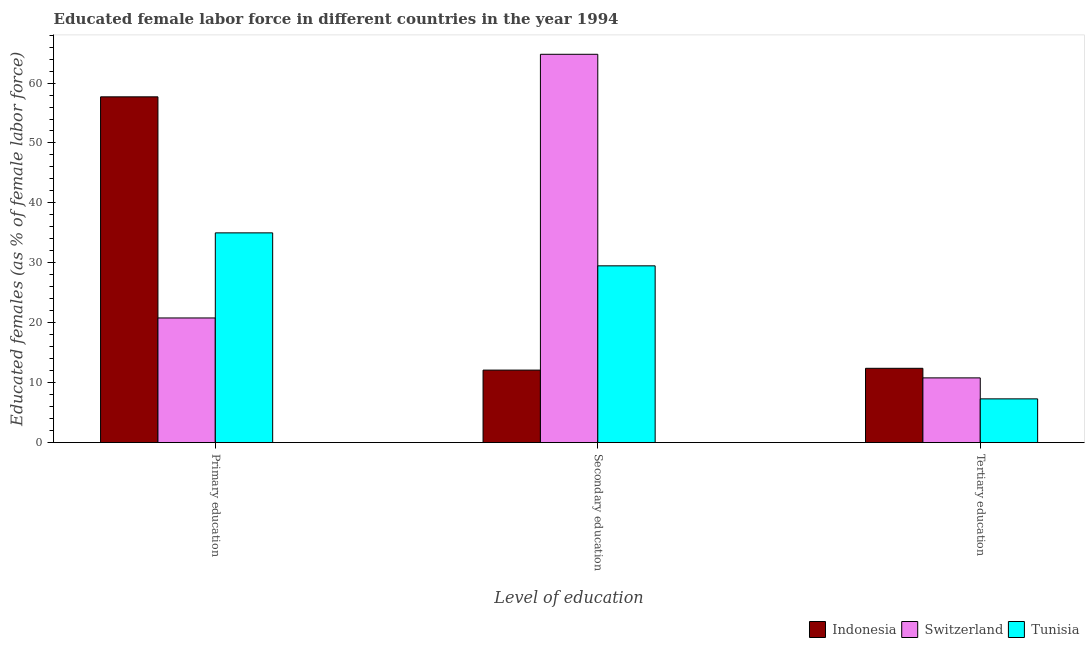How many different coloured bars are there?
Your answer should be compact. 3. How many groups of bars are there?
Make the answer very short. 3. How many bars are there on the 1st tick from the left?
Make the answer very short. 3. What is the percentage of female labor force who received tertiary education in Switzerland?
Offer a very short reply. 10.8. Across all countries, what is the maximum percentage of female labor force who received primary education?
Offer a very short reply. 57.7. Across all countries, what is the minimum percentage of female labor force who received secondary education?
Offer a terse response. 12.1. In which country was the percentage of female labor force who received tertiary education maximum?
Your answer should be compact. Indonesia. In which country was the percentage of female labor force who received secondary education minimum?
Provide a short and direct response. Indonesia. What is the total percentage of female labor force who received primary education in the graph?
Offer a very short reply. 113.5. What is the difference between the percentage of female labor force who received secondary education in Switzerland and that in Tunisia?
Ensure brevity in your answer.  35.3. What is the difference between the percentage of female labor force who received primary education in Indonesia and the percentage of female labor force who received secondary education in Switzerland?
Provide a succinct answer. -7.1. What is the average percentage of female labor force who received tertiary education per country?
Your response must be concise. 10.17. In how many countries, is the percentage of female labor force who received secondary education greater than 66 %?
Make the answer very short. 0. What is the ratio of the percentage of female labor force who received secondary education in Indonesia to that in Switzerland?
Offer a terse response. 0.19. What is the difference between the highest and the second highest percentage of female labor force who received secondary education?
Give a very brief answer. 35.3. What is the difference between the highest and the lowest percentage of female labor force who received primary education?
Give a very brief answer. 36.9. Is the sum of the percentage of female labor force who received secondary education in Indonesia and Switzerland greater than the maximum percentage of female labor force who received tertiary education across all countries?
Offer a terse response. Yes. What does the 2nd bar from the left in Primary education represents?
Offer a terse response. Switzerland. What does the 1st bar from the right in Primary education represents?
Give a very brief answer. Tunisia. Is it the case that in every country, the sum of the percentage of female labor force who received primary education and percentage of female labor force who received secondary education is greater than the percentage of female labor force who received tertiary education?
Your answer should be compact. Yes. How many bars are there?
Ensure brevity in your answer.  9. Are all the bars in the graph horizontal?
Offer a very short reply. No. How many countries are there in the graph?
Provide a short and direct response. 3. What is the difference between two consecutive major ticks on the Y-axis?
Your answer should be compact. 10. Does the graph contain any zero values?
Ensure brevity in your answer.  No. How many legend labels are there?
Your answer should be very brief. 3. What is the title of the graph?
Provide a short and direct response. Educated female labor force in different countries in the year 1994. What is the label or title of the X-axis?
Provide a short and direct response. Level of education. What is the label or title of the Y-axis?
Your answer should be very brief. Educated females (as % of female labor force). What is the Educated females (as % of female labor force) of Indonesia in Primary education?
Your answer should be compact. 57.7. What is the Educated females (as % of female labor force) of Switzerland in Primary education?
Provide a short and direct response. 20.8. What is the Educated females (as % of female labor force) of Tunisia in Primary education?
Make the answer very short. 35. What is the Educated females (as % of female labor force) of Indonesia in Secondary education?
Provide a succinct answer. 12.1. What is the Educated females (as % of female labor force) of Switzerland in Secondary education?
Provide a succinct answer. 64.8. What is the Educated females (as % of female labor force) of Tunisia in Secondary education?
Keep it short and to the point. 29.5. What is the Educated females (as % of female labor force) in Indonesia in Tertiary education?
Ensure brevity in your answer.  12.4. What is the Educated females (as % of female labor force) in Switzerland in Tertiary education?
Offer a terse response. 10.8. What is the Educated females (as % of female labor force) in Tunisia in Tertiary education?
Provide a succinct answer. 7.3. Across all Level of education, what is the maximum Educated females (as % of female labor force) of Indonesia?
Ensure brevity in your answer.  57.7. Across all Level of education, what is the maximum Educated females (as % of female labor force) in Switzerland?
Provide a short and direct response. 64.8. Across all Level of education, what is the minimum Educated females (as % of female labor force) in Indonesia?
Give a very brief answer. 12.1. Across all Level of education, what is the minimum Educated females (as % of female labor force) of Switzerland?
Your response must be concise. 10.8. Across all Level of education, what is the minimum Educated females (as % of female labor force) of Tunisia?
Provide a short and direct response. 7.3. What is the total Educated females (as % of female labor force) in Indonesia in the graph?
Provide a succinct answer. 82.2. What is the total Educated females (as % of female labor force) of Switzerland in the graph?
Keep it short and to the point. 96.4. What is the total Educated females (as % of female labor force) of Tunisia in the graph?
Make the answer very short. 71.8. What is the difference between the Educated females (as % of female labor force) of Indonesia in Primary education and that in Secondary education?
Keep it short and to the point. 45.6. What is the difference between the Educated females (as % of female labor force) in Switzerland in Primary education and that in Secondary education?
Keep it short and to the point. -44. What is the difference between the Educated females (as % of female labor force) of Tunisia in Primary education and that in Secondary education?
Make the answer very short. 5.5. What is the difference between the Educated females (as % of female labor force) in Indonesia in Primary education and that in Tertiary education?
Keep it short and to the point. 45.3. What is the difference between the Educated females (as % of female labor force) in Tunisia in Primary education and that in Tertiary education?
Your answer should be compact. 27.7. What is the difference between the Educated females (as % of female labor force) of Indonesia in Secondary education and that in Tertiary education?
Give a very brief answer. -0.3. What is the difference between the Educated females (as % of female labor force) in Indonesia in Primary education and the Educated females (as % of female labor force) in Switzerland in Secondary education?
Offer a very short reply. -7.1. What is the difference between the Educated females (as % of female labor force) in Indonesia in Primary education and the Educated females (as % of female labor force) in Tunisia in Secondary education?
Provide a short and direct response. 28.2. What is the difference between the Educated females (as % of female labor force) in Switzerland in Primary education and the Educated females (as % of female labor force) in Tunisia in Secondary education?
Ensure brevity in your answer.  -8.7. What is the difference between the Educated females (as % of female labor force) of Indonesia in Primary education and the Educated females (as % of female labor force) of Switzerland in Tertiary education?
Your response must be concise. 46.9. What is the difference between the Educated females (as % of female labor force) of Indonesia in Primary education and the Educated females (as % of female labor force) of Tunisia in Tertiary education?
Ensure brevity in your answer.  50.4. What is the difference between the Educated females (as % of female labor force) of Switzerland in Primary education and the Educated females (as % of female labor force) of Tunisia in Tertiary education?
Give a very brief answer. 13.5. What is the difference between the Educated females (as % of female labor force) of Indonesia in Secondary education and the Educated females (as % of female labor force) of Switzerland in Tertiary education?
Ensure brevity in your answer.  1.3. What is the difference between the Educated females (as % of female labor force) of Switzerland in Secondary education and the Educated females (as % of female labor force) of Tunisia in Tertiary education?
Your answer should be very brief. 57.5. What is the average Educated females (as % of female labor force) in Indonesia per Level of education?
Offer a terse response. 27.4. What is the average Educated females (as % of female labor force) of Switzerland per Level of education?
Offer a terse response. 32.13. What is the average Educated females (as % of female labor force) of Tunisia per Level of education?
Provide a succinct answer. 23.93. What is the difference between the Educated females (as % of female labor force) in Indonesia and Educated females (as % of female labor force) in Switzerland in Primary education?
Offer a very short reply. 36.9. What is the difference between the Educated females (as % of female labor force) of Indonesia and Educated females (as % of female labor force) of Tunisia in Primary education?
Ensure brevity in your answer.  22.7. What is the difference between the Educated females (as % of female labor force) in Switzerland and Educated females (as % of female labor force) in Tunisia in Primary education?
Keep it short and to the point. -14.2. What is the difference between the Educated females (as % of female labor force) of Indonesia and Educated females (as % of female labor force) of Switzerland in Secondary education?
Your answer should be compact. -52.7. What is the difference between the Educated females (as % of female labor force) in Indonesia and Educated females (as % of female labor force) in Tunisia in Secondary education?
Your response must be concise. -17.4. What is the difference between the Educated females (as % of female labor force) of Switzerland and Educated females (as % of female labor force) of Tunisia in Secondary education?
Your answer should be compact. 35.3. What is the difference between the Educated females (as % of female labor force) in Indonesia and Educated females (as % of female labor force) in Tunisia in Tertiary education?
Provide a succinct answer. 5.1. What is the difference between the Educated females (as % of female labor force) of Switzerland and Educated females (as % of female labor force) of Tunisia in Tertiary education?
Give a very brief answer. 3.5. What is the ratio of the Educated females (as % of female labor force) of Indonesia in Primary education to that in Secondary education?
Keep it short and to the point. 4.77. What is the ratio of the Educated females (as % of female labor force) of Switzerland in Primary education to that in Secondary education?
Provide a short and direct response. 0.32. What is the ratio of the Educated females (as % of female labor force) of Tunisia in Primary education to that in Secondary education?
Your response must be concise. 1.19. What is the ratio of the Educated females (as % of female labor force) in Indonesia in Primary education to that in Tertiary education?
Make the answer very short. 4.65. What is the ratio of the Educated females (as % of female labor force) in Switzerland in Primary education to that in Tertiary education?
Provide a short and direct response. 1.93. What is the ratio of the Educated females (as % of female labor force) of Tunisia in Primary education to that in Tertiary education?
Your answer should be very brief. 4.79. What is the ratio of the Educated females (as % of female labor force) of Indonesia in Secondary education to that in Tertiary education?
Provide a succinct answer. 0.98. What is the ratio of the Educated females (as % of female labor force) in Switzerland in Secondary education to that in Tertiary education?
Provide a succinct answer. 6. What is the ratio of the Educated females (as % of female labor force) of Tunisia in Secondary education to that in Tertiary education?
Your answer should be very brief. 4.04. What is the difference between the highest and the second highest Educated females (as % of female labor force) of Indonesia?
Provide a succinct answer. 45.3. What is the difference between the highest and the second highest Educated females (as % of female labor force) in Tunisia?
Your answer should be very brief. 5.5. What is the difference between the highest and the lowest Educated females (as % of female labor force) in Indonesia?
Offer a very short reply. 45.6. What is the difference between the highest and the lowest Educated females (as % of female labor force) of Tunisia?
Your answer should be very brief. 27.7. 